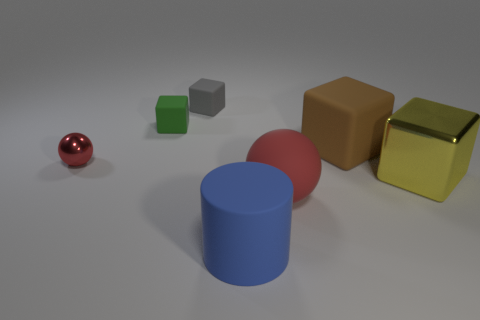Subtract all large yellow metallic blocks. How many blocks are left? 3 Subtract all purple blocks. Subtract all cyan cylinders. How many blocks are left? 4 Add 1 tiny metal things. How many objects exist? 8 Subtract all blocks. How many objects are left? 3 Add 6 large matte balls. How many large matte balls exist? 7 Subtract 1 blue cylinders. How many objects are left? 6 Subtract all small green cubes. Subtract all large blue things. How many objects are left? 5 Add 6 blue rubber things. How many blue rubber things are left? 7 